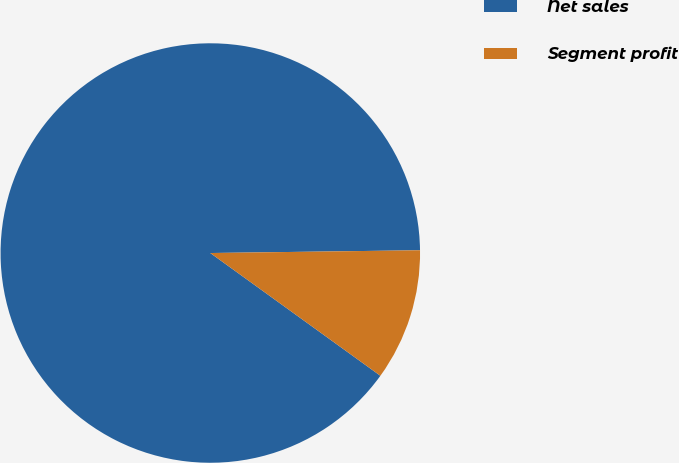Convert chart. <chart><loc_0><loc_0><loc_500><loc_500><pie_chart><fcel>Net sales<fcel>Segment profit<nl><fcel>89.84%<fcel>10.16%<nl></chart> 